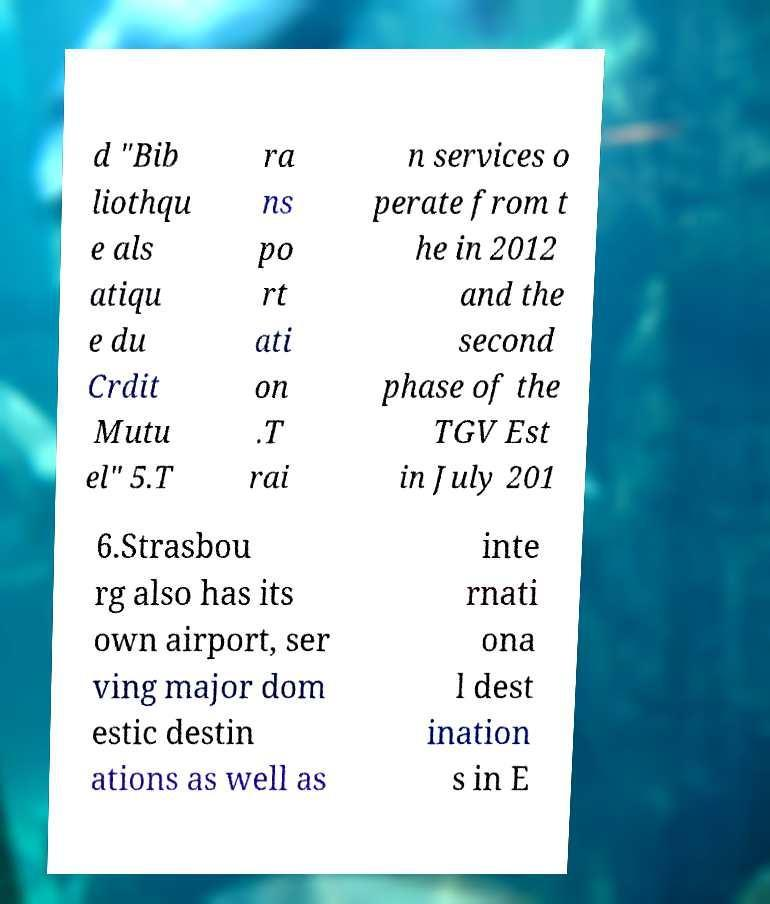Please read and relay the text visible in this image. What does it say? d "Bib liothqu e als atiqu e du Crdit Mutu el" 5.T ra ns po rt ati on .T rai n services o perate from t he in 2012 and the second phase of the TGV Est in July 201 6.Strasbou rg also has its own airport, ser ving major dom estic destin ations as well as inte rnati ona l dest ination s in E 